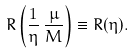<formula> <loc_0><loc_0><loc_500><loc_500>R \left ( \frac { 1 } { \eta } \, { \frac { \mu } { M } } \right ) \equiv R ( \eta ) .</formula> 